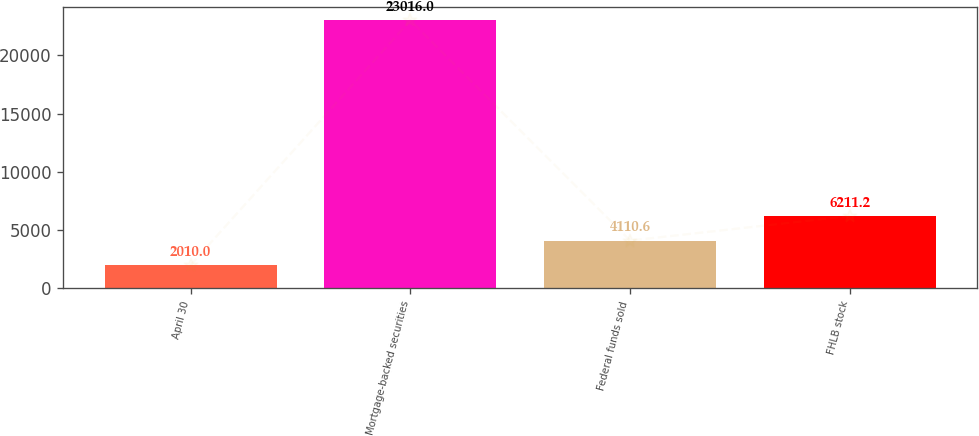<chart> <loc_0><loc_0><loc_500><loc_500><bar_chart><fcel>April 30<fcel>Mortgage-backed securities<fcel>Federal funds sold<fcel>FHLB stock<nl><fcel>2010<fcel>23016<fcel>4110.6<fcel>6211.2<nl></chart> 